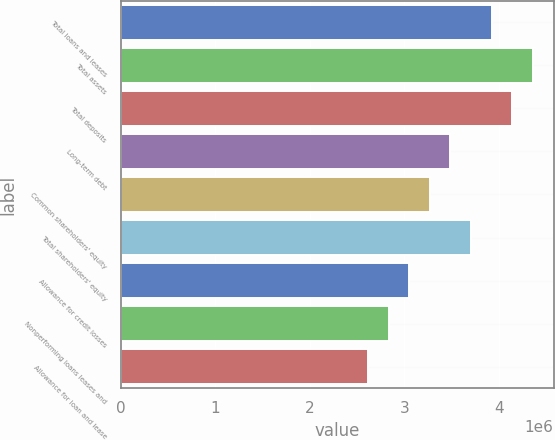<chart> <loc_0><loc_0><loc_500><loc_500><bar_chart><fcel>Total loans and leases<fcel>Total assets<fcel>Total deposits<fcel>Long-term debt<fcel>Common shareholders' equity<fcel>Total shareholders' equity<fcel>Allowance for credit losses<fcel>Nonperforming loans leases and<fcel>Allowance for loan and lease<nl><fcel>3.92485e+06<fcel>4.36094e+06<fcel>4.1429e+06<fcel>3.48875e+06<fcel>3.27071e+06<fcel>3.7068e+06<fcel>3.05266e+06<fcel>2.83461e+06<fcel>2.61657e+06<nl></chart> 